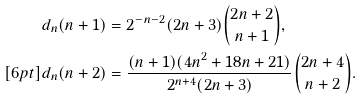Convert formula to latex. <formula><loc_0><loc_0><loc_500><loc_500>d _ { n } ( n + 1 ) & = 2 ^ { - n - 2 } ( 2 n + 3 ) { 2 n + 2 \choose n + 1 } , \\ [ 6 p t ] d _ { n } ( n + 2 ) & = \frac { ( n + 1 ) ( 4 n ^ { 2 } + 1 8 n + 2 1 ) } { 2 ^ { n + 4 } ( 2 n + 3 ) } { 2 n + 4 \choose n + 2 } .</formula> 